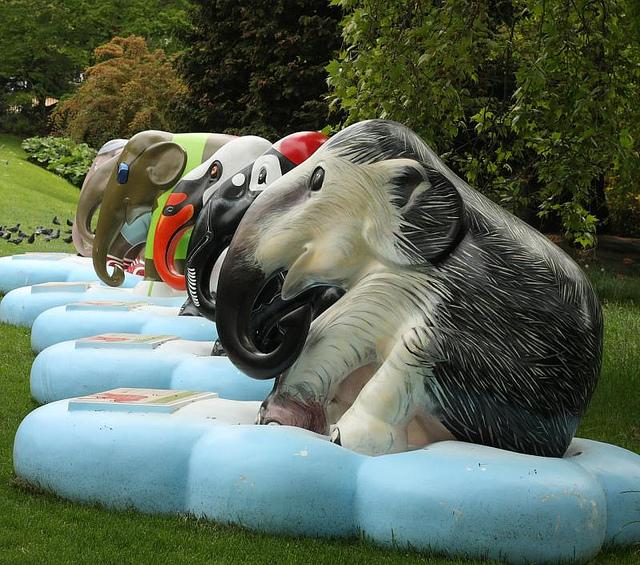How would these animals be described? elephant sculptures 